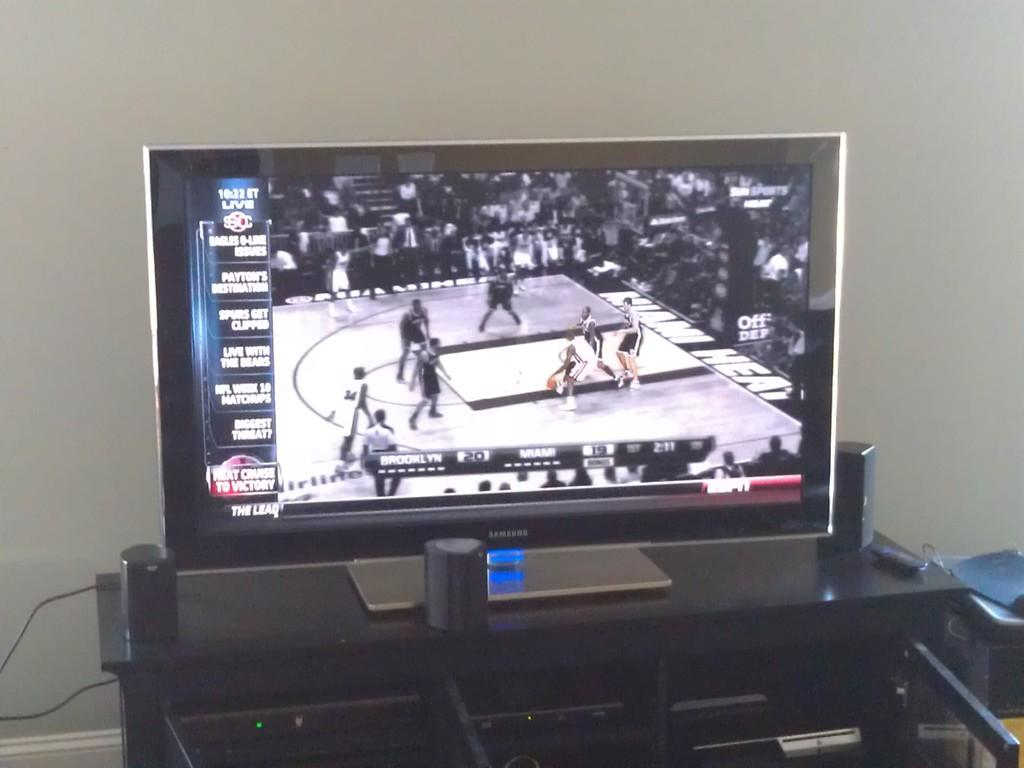<image>
Write a terse but informative summary of the picture. A flat screen TV made by Samsung has a basketball game on it between Brooklyn and Miami. 